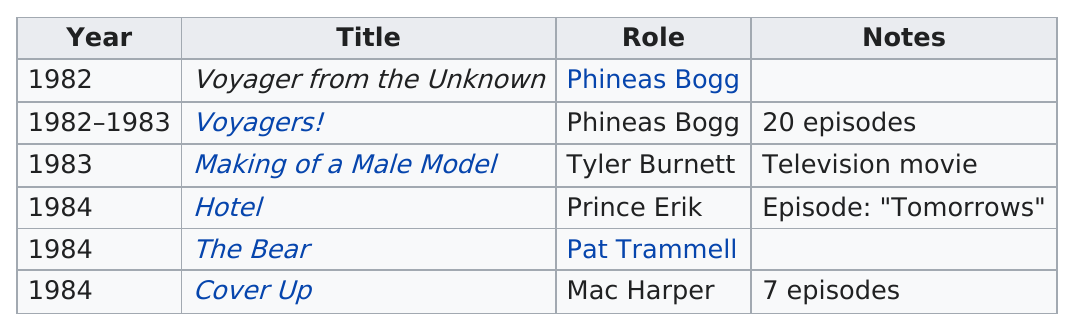Highlight a few significant elements in this photo. Phineas Bogg did not play the role in 4 out of the titles on this list. In 1984, he played the role of Mac Harper and also Pat Trammell. 